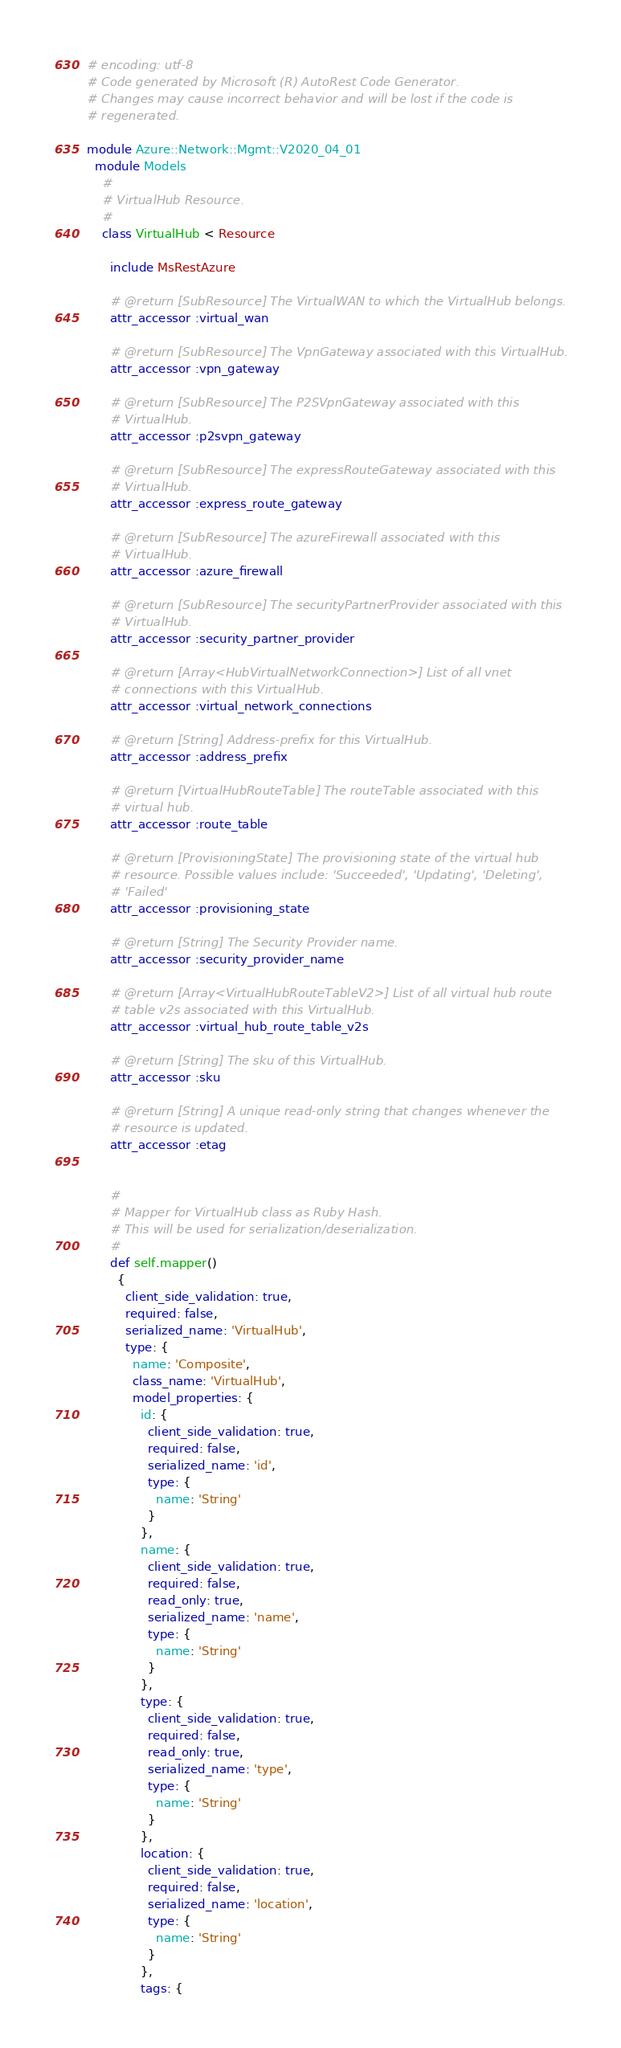Convert code to text. <code><loc_0><loc_0><loc_500><loc_500><_Ruby_># encoding: utf-8
# Code generated by Microsoft (R) AutoRest Code Generator.
# Changes may cause incorrect behavior and will be lost if the code is
# regenerated.

module Azure::Network::Mgmt::V2020_04_01
  module Models
    #
    # VirtualHub Resource.
    #
    class VirtualHub < Resource

      include MsRestAzure

      # @return [SubResource] The VirtualWAN to which the VirtualHub belongs.
      attr_accessor :virtual_wan

      # @return [SubResource] The VpnGateway associated with this VirtualHub.
      attr_accessor :vpn_gateway

      # @return [SubResource] The P2SVpnGateway associated with this
      # VirtualHub.
      attr_accessor :p2svpn_gateway

      # @return [SubResource] The expressRouteGateway associated with this
      # VirtualHub.
      attr_accessor :express_route_gateway

      # @return [SubResource] The azureFirewall associated with this
      # VirtualHub.
      attr_accessor :azure_firewall

      # @return [SubResource] The securityPartnerProvider associated with this
      # VirtualHub.
      attr_accessor :security_partner_provider

      # @return [Array<HubVirtualNetworkConnection>] List of all vnet
      # connections with this VirtualHub.
      attr_accessor :virtual_network_connections

      # @return [String] Address-prefix for this VirtualHub.
      attr_accessor :address_prefix

      # @return [VirtualHubRouteTable] The routeTable associated with this
      # virtual hub.
      attr_accessor :route_table

      # @return [ProvisioningState] The provisioning state of the virtual hub
      # resource. Possible values include: 'Succeeded', 'Updating', 'Deleting',
      # 'Failed'
      attr_accessor :provisioning_state

      # @return [String] The Security Provider name.
      attr_accessor :security_provider_name

      # @return [Array<VirtualHubRouteTableV2>] List of all virtual hub route
      # table v2s associated with this VirtualHub.
      attr_accessor :virtual_hub_route_table_v2s

      # @return [String] The sku of this VirtualHub.
      attr_accessor :sku

      # @return [String] A unique read-only string that changes whenever the
      # resource is updated.
      attr_accessor :etag


      #
      # Mapper for VirtualHub class as Ruby Hash.
      # This will be used for serialization/deserialization.
      #
      def self.mapper()
        {
          client_side_validation: true,
          required: false,
          serialized_name: 'VirtualHub',
          type: {
            name: 'Composite',
            class_name: 'VirtualHub',
            model_properties: {
              id: {
                client_side_validation: true,
                required: false,
                serialized_name: 'id',
                type: {
                  name: 'String'
                }
              },
              name: {
                client_side_validation: true,
                required: false,
                read_only: true,
                serialized_name: 'name',
                type: {
                  name: 'String'
                }
              },
              type: {
                client_side_validation: true,
                required: false,
                read_only: true,
                serialized_name: 'type',
                type: {
                  name: 'String'
                }
              },
              location: {
                client_side_validation: true,
                required: false,
                serialized_name: 'location',
                type: {
                  name: 'String'
                }
              },
              tags: {</code> 